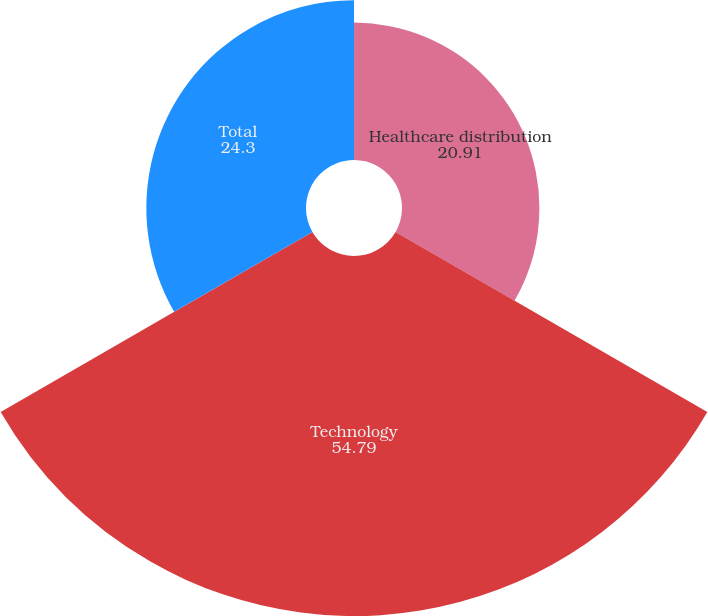<chart> <loc_0><loc_0><loc_500><loc_500><pie_chart><fcel>Healthcare distribution<fcel>Technology<fcel>Total<nl><fcel>20.91%<fcel>54.79%<fcel>24.3%<nl></chart> 